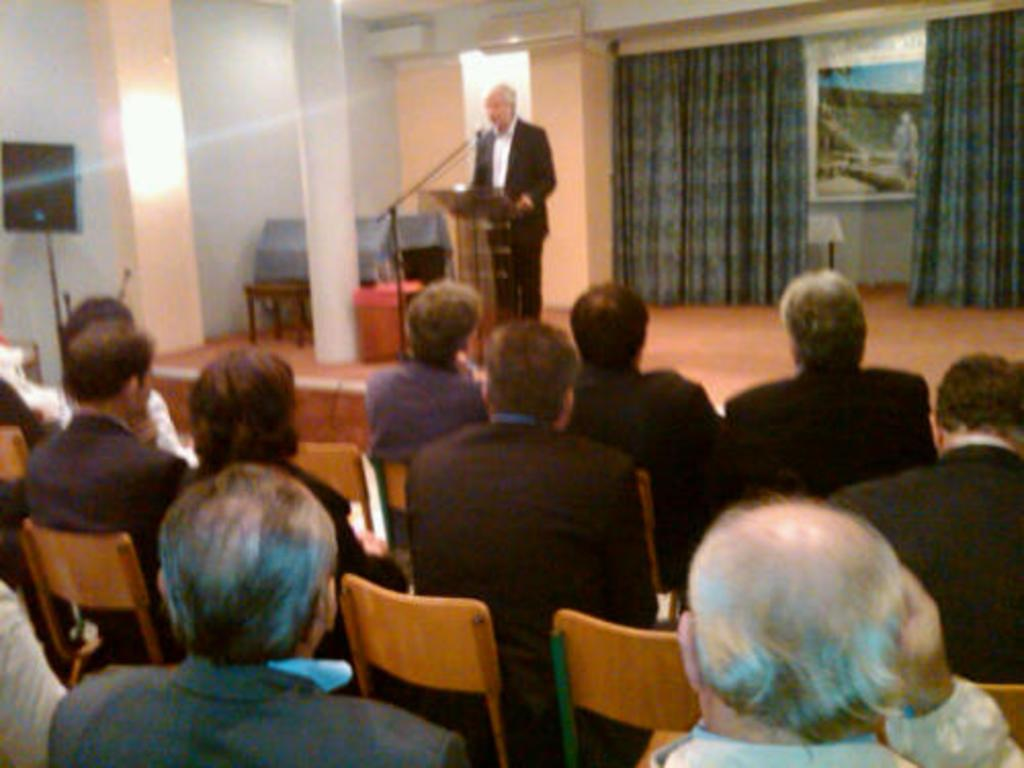What is the setting of the image? The image is inside a room. What are the people in the image doing? There are persons sitting on chairs, and one person is standing. What is the standing person doing? The standing person is in front of a podium with a mic. What can be seen on the walls in the room? There is a curtain and a poster on the wall. What type of stove is visible in the image? There is no stove present in the image. What vegetable is being discussed by the standing person in the image? The image does not provide information about the topic of discussion, and there is no mention of a vegetable, specifically cabbage, in the image. 